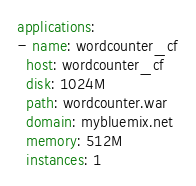<code> <loc_0><loc_0><loc_500><loc_500><_YAML_>applications:
- name: wordcounter_cf
  host: wordcounter_cf
  disk: 1024M
  path: wordcounter.war
  domain: mybluemix.net
  memory: 512M
  instances: 1</code> 